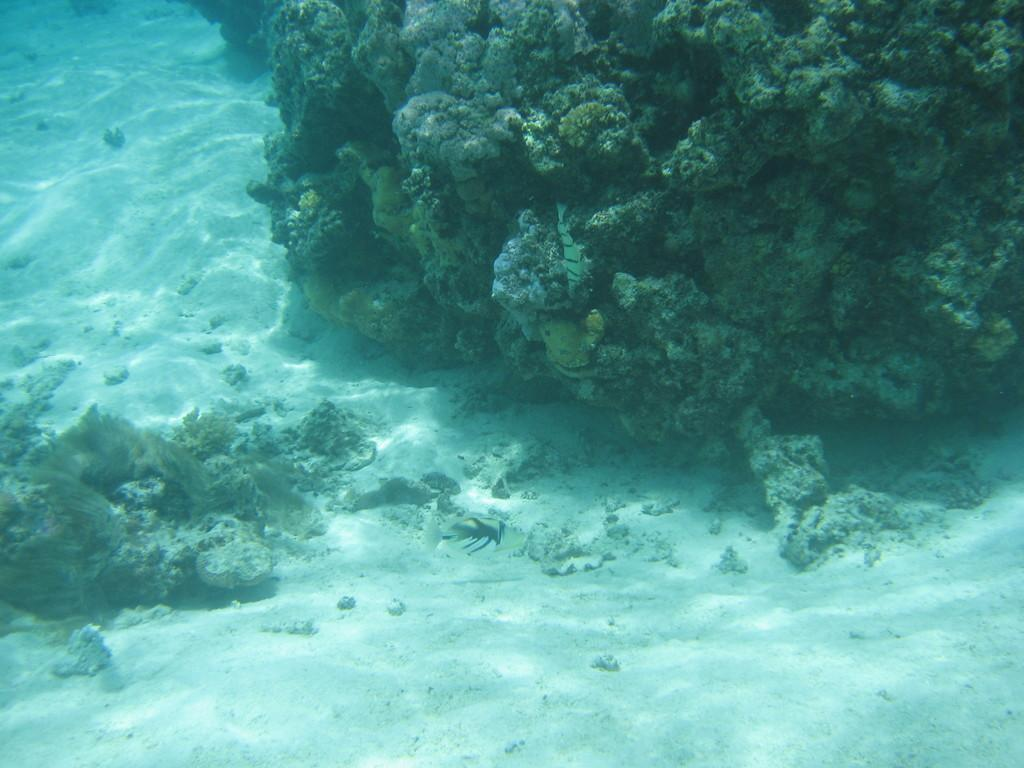What is visible in the image? There is water visible in the image. Are there any objects in the water? Yes, there are objects in the water. What type of bat can be seen flying over the water in the image? There is no bat visible in the image; it only shows water and objects in the water. 